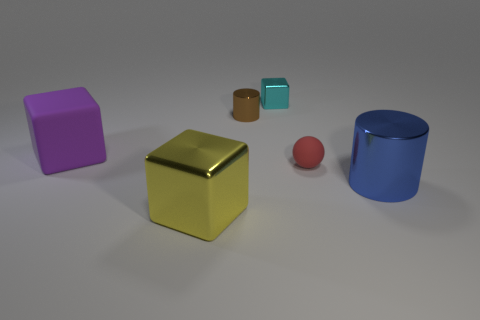Is there any other thing that is the same shape as the small rubber object?
Offer a terse response. No. What number of objects are either tiny cyan metal objects or tiny red shiny blocks?
Provide a succinct answer. 1. There is a thing to the right of the tiny object that is to the right of the tiny cyan block; what shape is it?
Your answer should be very brief. Cylinder. How many other objects are there of the same material as the purple cube?
Give a very brief answer. 1. Do the tiny brown object and the tiny thing in front of the purple matte object have the same material?
Give a very brief answer. No. How many things are either objects that are right of the yellow cube or shiny cylinders that are on the right side of the tiny red thing?
Provide a succinct answer. 4. How many other things are the same color as the tiny rubber thing?
Ensure brevity in your answer.  0. Are there more tiny rubber things right of the large blue object than small red spheres to the right of the tiny rubber sphere?
Provide a succinct answer. No. What number of cylinders are either purple matte things or big brown metal things?
Ensure brevity in your answer.  0. How many objects are either big objects that are on the right side of the yellow cube or yellow shiny things?
Your response must be concise. 2. 